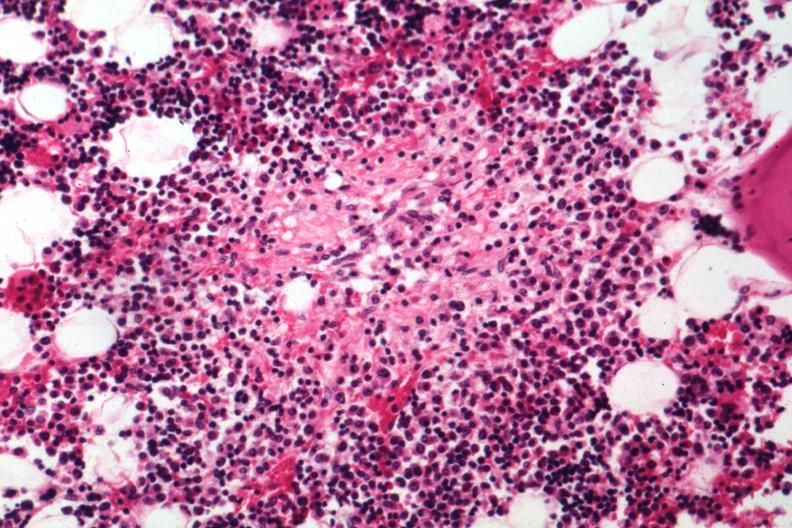s bone marrow present?
Answer the question using a single word or phrase. Yes 